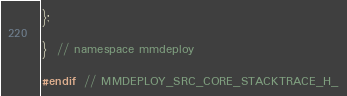<code> <loc_0><loc_0><loc_500><loc_500><_C_>};

}  // namespace mmdeploy

#endif  // MMDEPLOY_SRC_CORE_STACKTRACE_H_
</code> 